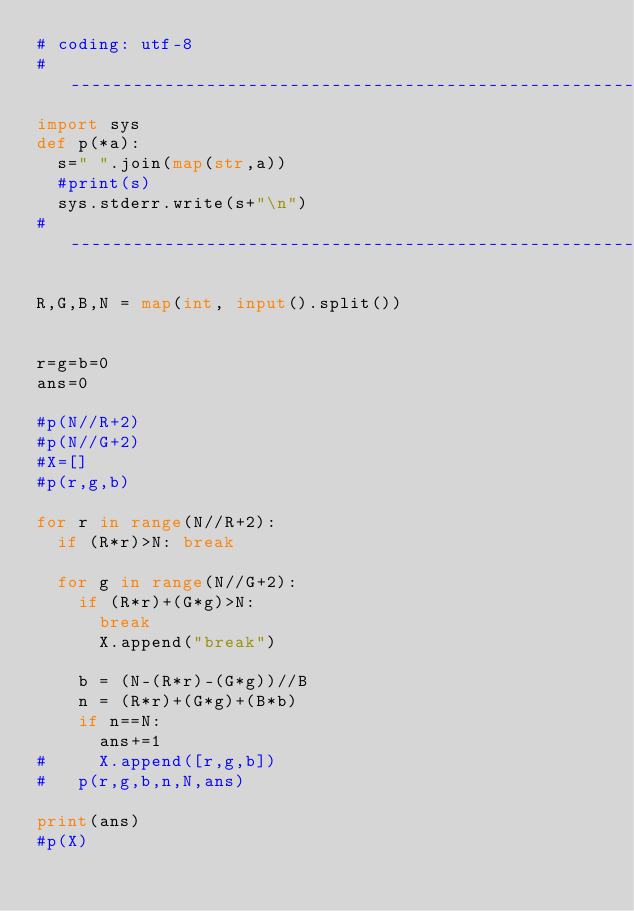<code> <loc_0><loc_0><loc_500><loc_500><_Python_># coding: utf-8
#-------------------------------------------------------------------
import sys
def p(*a):
  s=" ".join(map(str,a))
  #print(s)
  sys.stderr.write(s+"\n")
#-------------------------------------------------------------------

R,G,B,N = map(int, input().split())


r=g=b=0
ans=0

#p(N//R+2)
#p(N//G+2)
#X=[]
#p(r,g,b)

for r in range(N//R+2):
	if (R*r)>N: break

	for g in range(N//G+2):
		if (R*r)+(G*g)>N:
			break
			X.append("break")
		
		b = (N-(R*r)-(G*g))//B
		n = (R*r)+(G*g)+(B*b)
		if n==N:
			ans+=1
#			X.append([r,g,b])
#		p(r,g,b,n,N,ans)

print(ans)
#p(X)
</code> 